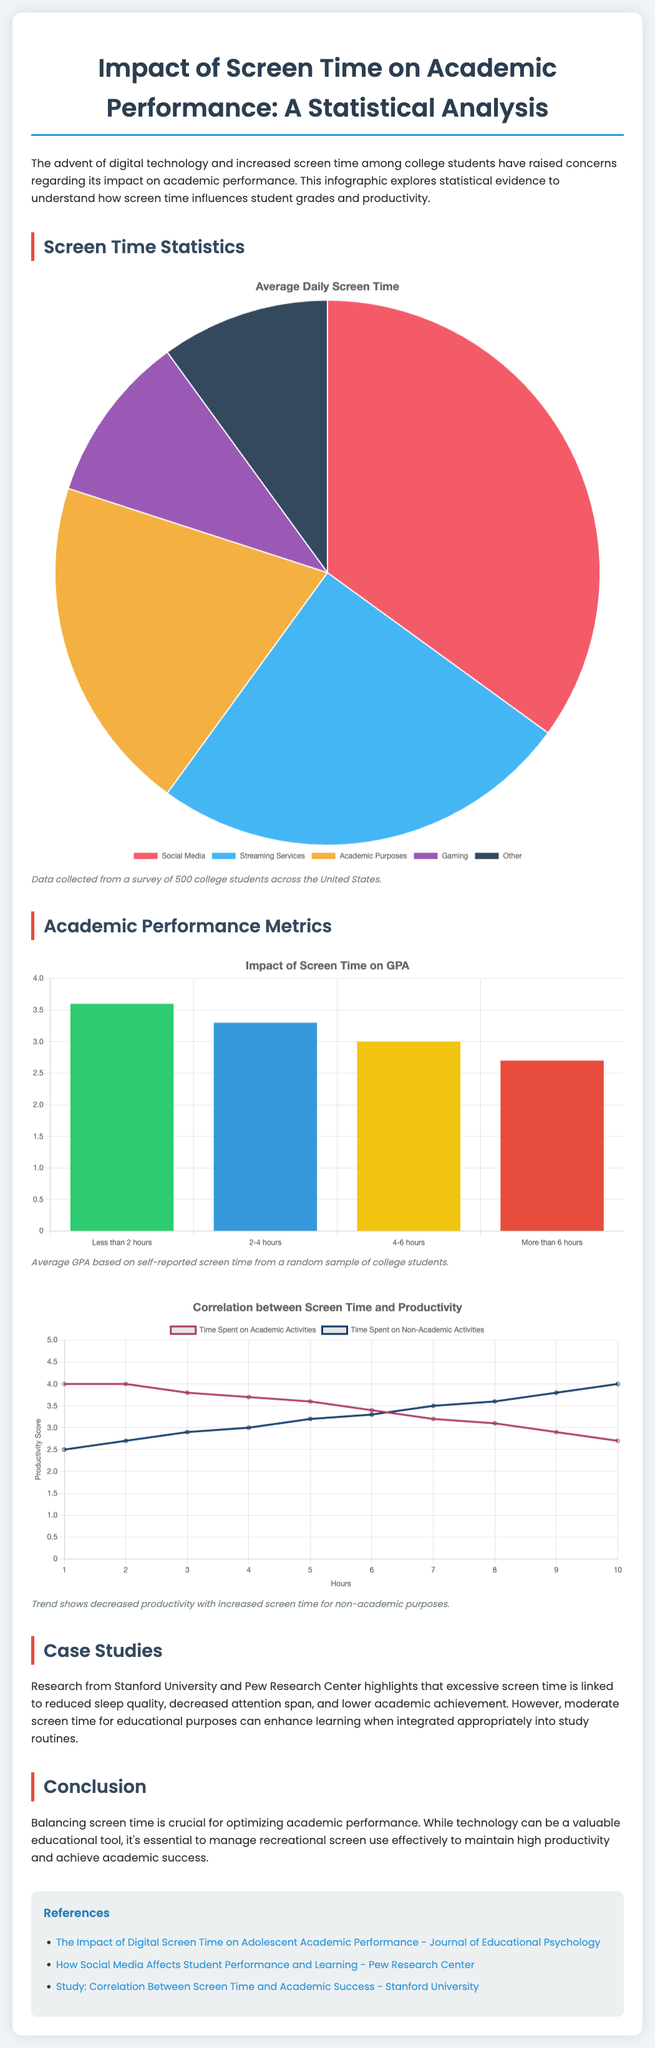What is the average GPA for students who spend less than 2 hours on screens? The average GPA for students who spend less than 2 hours on screens is reported in the GPA Chart, which shows a value of 3.6.
Answer: 3.6 What is the main concern regarding increased screen time among college students? The main concern is its impact on academic performance, which is explored in the introductory paragraph of the document.
Answer: Impact on academic performance How long is the average daily screen time for social media? The specific percentage of average daily screen time for social media is listed in the Screen Time Statistics, which is 35%.
Answer: 35% What trend is observed in productivity based on the line chart? The line chart illustrates how productivity decreases with increased screen time for non-academic purposes.
Answer: Decreased productivity What references are provided at the end of the document? The references at the end include studies and articles that connect screen time to academic performance, such as "The Impact of Digital Screen Time on Adolescent Academic Performance."
Answer: Studies and articles What is the recommended balance for screen time regarding academic performance? The conclusion emphasizes balancing screen time to optimize academic performance while managing recreational use effectively.
Answer: Balancing screen time What category uses the least average daily screen time according to the pie chart? The category with the least average daily screen time listed in the pie chart is "Gaming," which accounts for 10%.
Answer: Gaming What is depicted in the productivity correlation chart? The productivity correlation chart depicts the relationship between time spent on academic and non-academic activities regarding productivity scores.
Answer: Relationship between screen time and productivity 